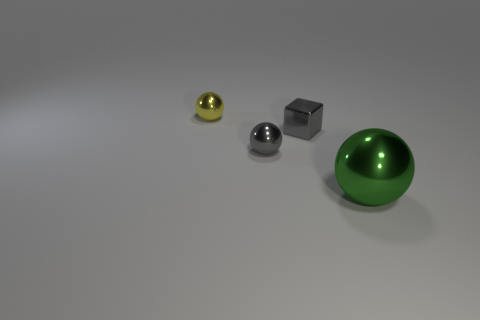Subtract all yellow balls. How many balls are left? 2 Subtract all small gray metal balls. How many balls are left? 2 Add 1 metal balls. How many objects exist? 5 Subtract 0 red spheres. How many objects are left? 4 Subtract all spheres. How many objects are left? 1 Subtract all yellow blocks. Subtract all red cylinders. How many blocks are left? 1 Subtract all brown cylinders. How many yellow balls are left? 1 Subtract all gray cubes. Subtract all gray spheres. How many objects are left? 2 Add 4 small metallic balls. How many small metallic balls are left? 6 Add 2 small metallic balls. How many small metallic balls exist? 4 